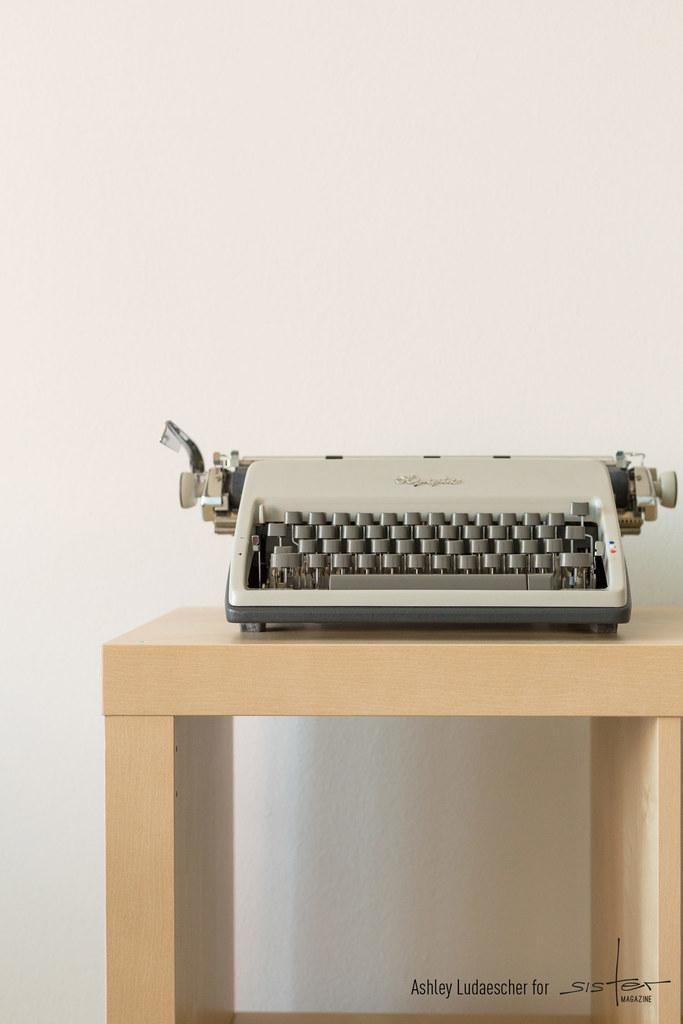What is the main object in the image? There is a typing machine in the image. Where is the typing machine placed? The typing machine is on a wooden table. Can you describe any additional features in the image? There is a watermark in the bottom left corner of the image, and a white wall is visible in the background. What type of songs can be heard coming from the typing machine in the image? There are no songs coming from the typing machine in the image, as it is a mechanical device for typing and not a musical instrument. 